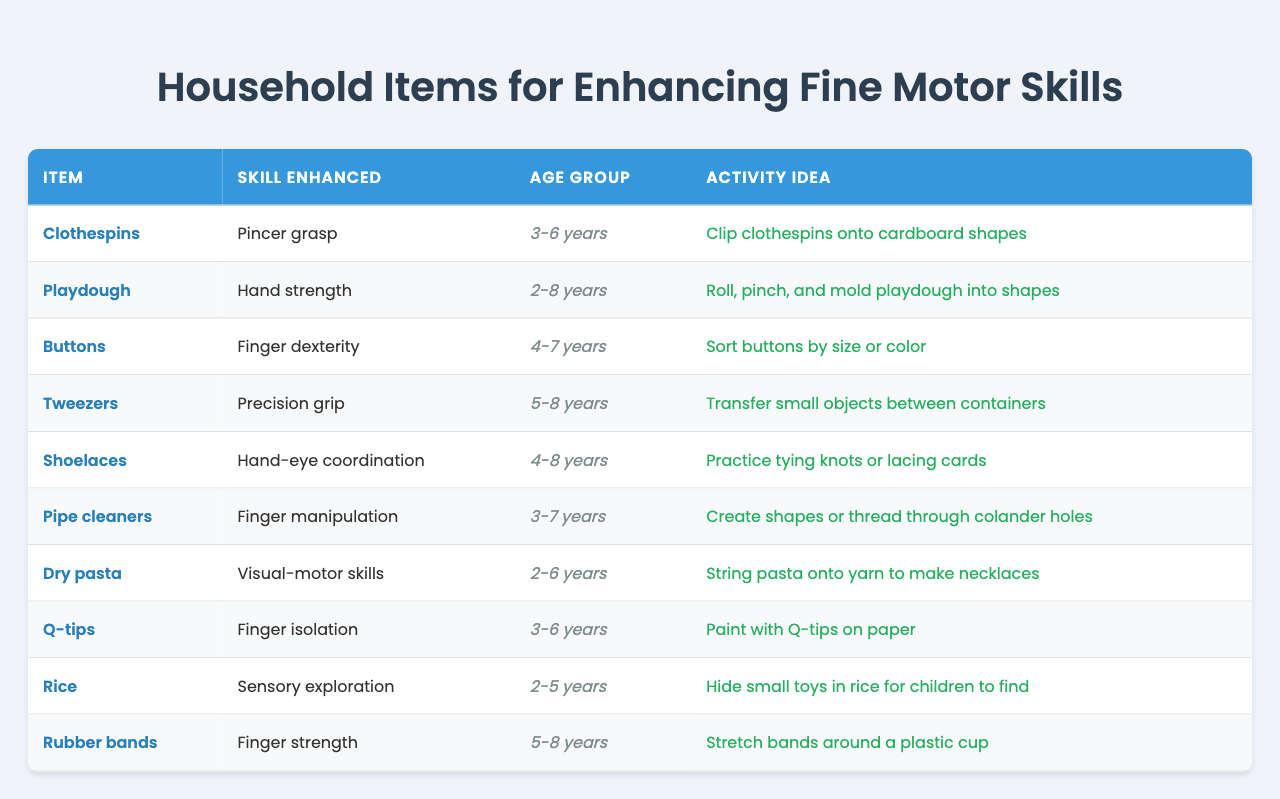What item enhances pincer grasp skills? The table lists "Clothespins" as the item that enhances pincer grasp skills.
Answer: Clothespins Which age group is suitable for the activity with playdough? The table indicates that the age group suitable for the playdough activity is "2-8 years."
Answer: 2-8 years How many items listed enhance fine motor skills for the age group of 3-6 years? There are a total of 4 items (Clothespins, Pipe cleaners, Q-tips, Rice) that enhance fine motor skills for the age group of 3-6 years.
Answer: 4 Are rubber bands used to enhance finger strength? Yes, according to the table, rubber bands enhance finger strength.
Answer: Yes What is the activity idea for using buttons? The table states that the activity idea for buttons is to sort them by size or color.
Answer: Sort buttons by size or color Which item improves hand-eye coordination, and what is the suggested activity? The item that improves hand-eye coordination is "Shoelaces," and the suggested activity is to practice tying knots or lacing cards.
Answer: Shoelaces; practice tying knots or lacing cards How would you compare the age range for tweezers and rubber bands? "Tweezers" are for ages "5-8 years," while "Rubber bands" cater to the same age group of "5-8 years," making them equal in age range.
Answer: Equal age range (5-8 years) What is the difference in the age ranges between the item that uses dry pasta and the item that uses rice? "Dry pasta" is for ages "2-6 years" and "Rice" is for ages "2-5 years." The difference in maximum ages is 1 year, so "Dry pasta" can be used for 1 additional year compared to rice.
Answer: 1 year List the skills enhanced by items suitable for children aged 4 years. The items suitable for 4 years enhance finger dexterity (Buttons), hand-eye coordination (Shoelaces), and finger manipulation (Pipe cleaners).
Answer: Finger dexterity, hand-eye coordination, finger manipulation If a child wishes to practice finger isolation, which item should they use, and what activity is suggested? The table suggests using "Q-tips" for practicing finger isolation, and the activity is to paint with Q-tips on paper.
Answer: Q-tips; paint with Q-tips on paper Which item would best develop visual-motor skills based on the table's information? "Dry pasta" is identified in the table as enhancing visual-motor skills through the activity of stringing pasta onto yarn.
Answer: Dry pasta 